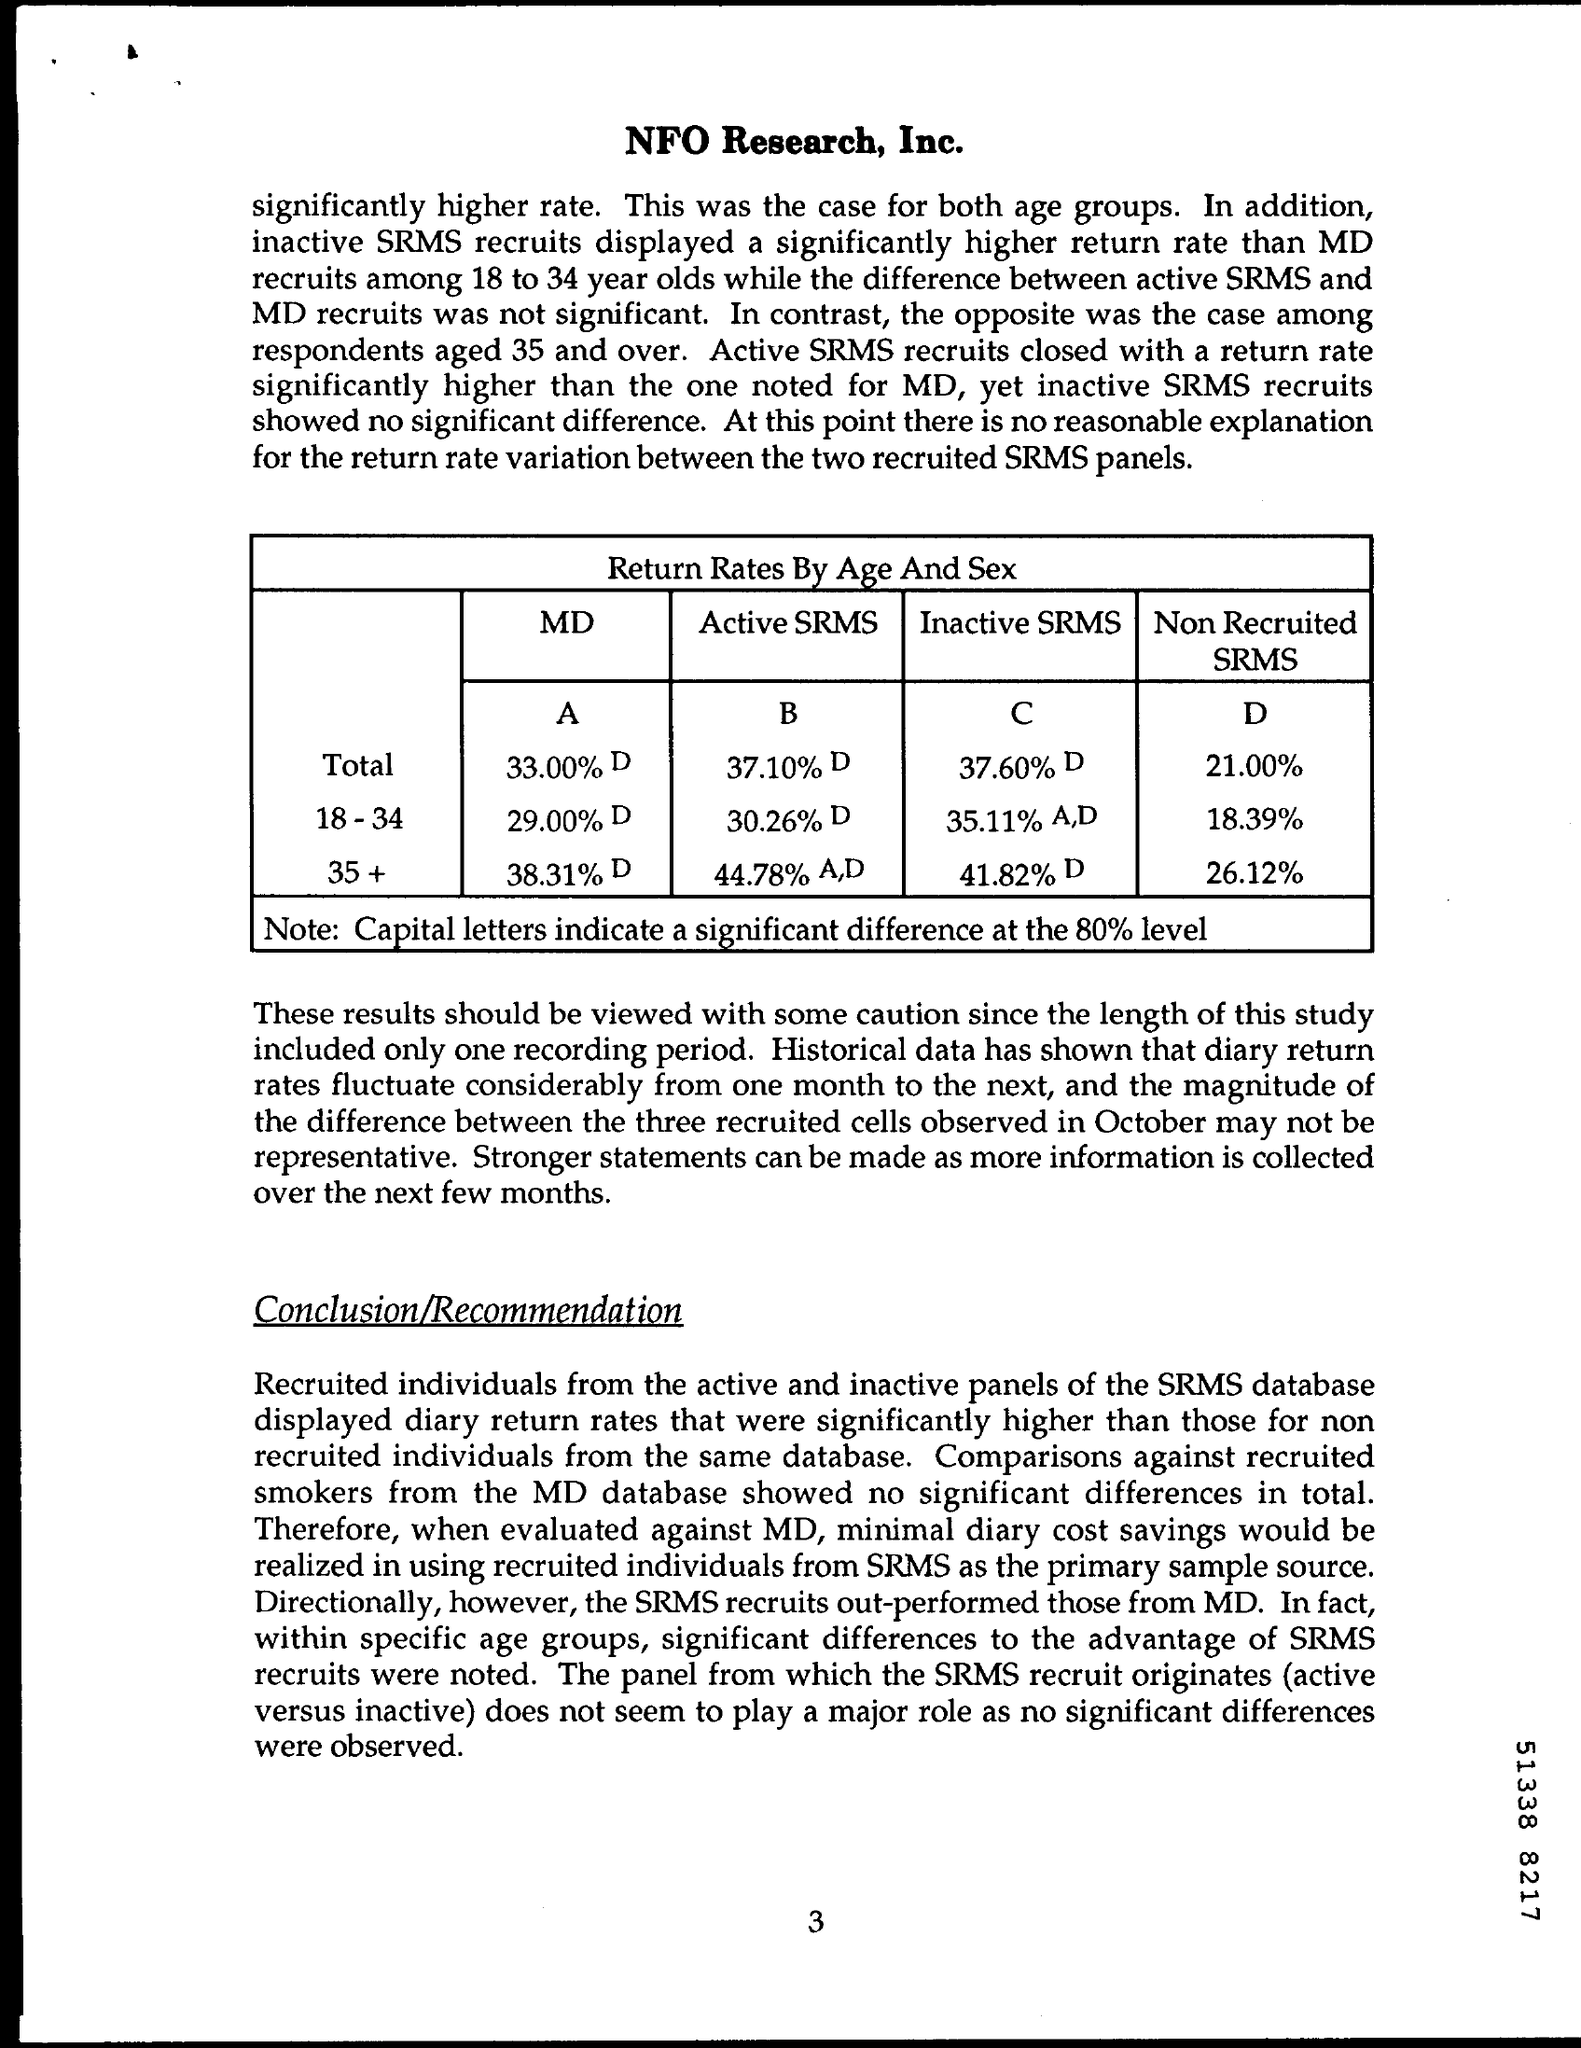What does the acronym SRMS stand for in this document? The acronym SRMS in the document likely stands for a specialized research or statistical method, but it isn't defined within this specific page, so the full name cannot be determined from the given context. 